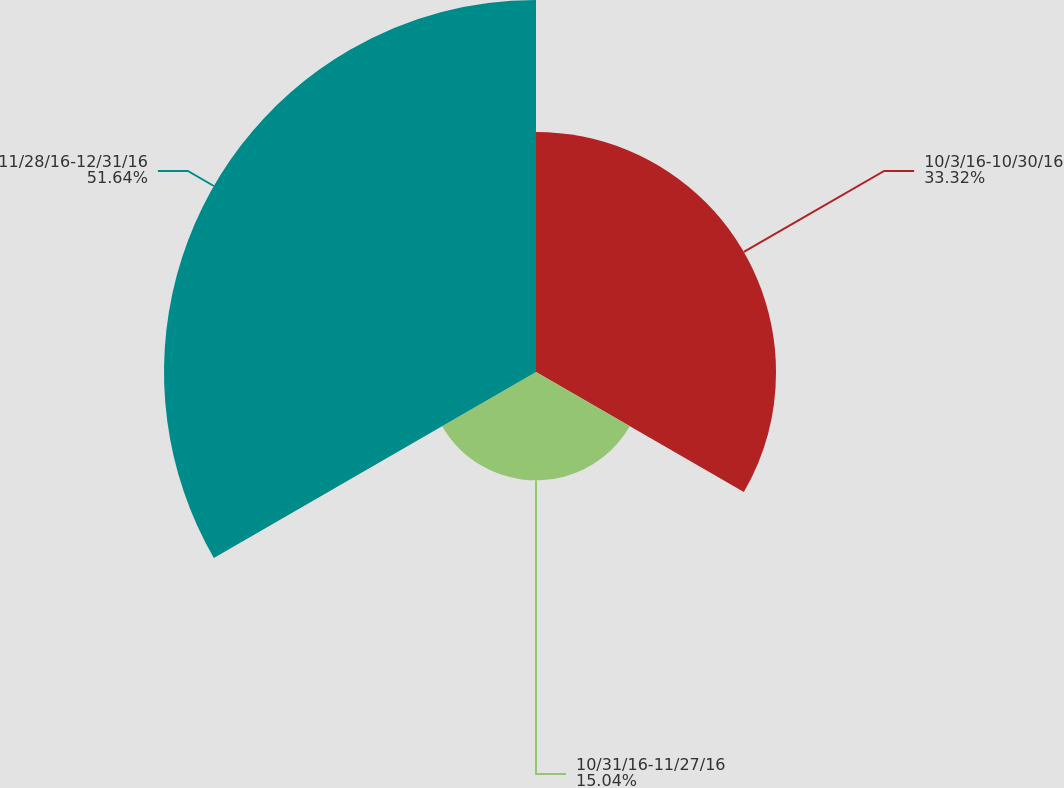Convert chart. <chart><loc_0><loc_0><loc_500><loc_500><pie_chart><fcel>10/3/16-10/30/16<fcel>10/31/16-11/27/16<fcel>11/28/16-12/31/16<nl><fcel>33.32%<fcel>15.04%<fcel>51.64%<nl></chart> 